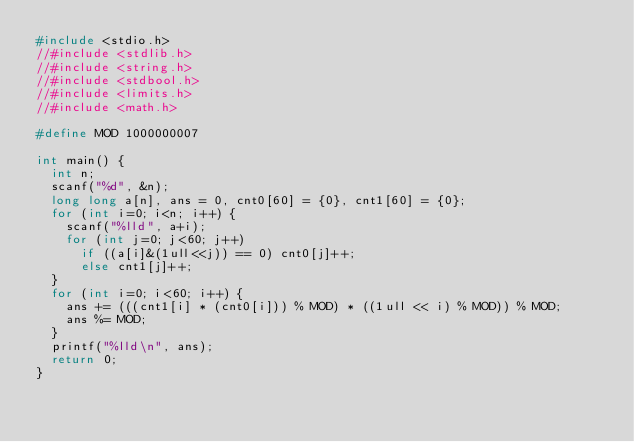<code> <loc_0><loc_0><loc_500><loc_500><_C_>#include <stdio.h>
//#include <stdlib.h>
//#include <string.h>
//#include <stdbool.h>
//#include <limits.h>
//#include <math.h>

#define MOD 1000000007

int main() {
  int n;
  scanf("%d", &n);
  long long a[n], ans = 0, cnt0[60] = {0}, cnt1[60] = {0};
  for (int i=0; i<n; i++) {
    scanf("%lld", a+i);
    for (int j=0; j<60; j++)
      if ((a[i]&(1ull<<j)) == 0) cnt0[j]++;
      else cnt1[j]++;
  }
  for (int i=0; i<60; i++) {
    ans += (((cnt1[i] * (cnt0[i])) % MOD) * ((1ull << i) % MOD)) % MOD;
    ans %= MOD;
  }
  printf("%lld\n", ans);
  return 0;
}
</code> 